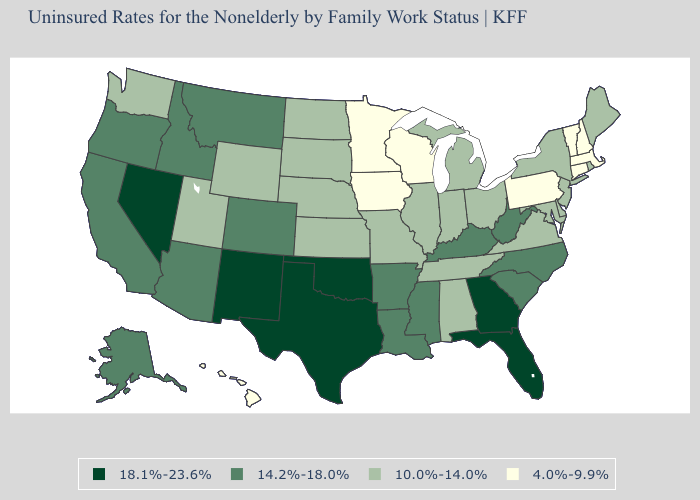What is the value of Kansas?
Answer briefly. 10.0%-14.0%. What is the highest value in the USA?
Write a very short answer. 18.1%-23.6%. What is the highest value in states that border Vermont?
Concise answer only. 10.0%-14.0%. What is the value of Arkansas?
Quick response, please. 14.2%-18.0%. Does Iowa have a lower value than Oklahoma?
Concise answer only. Yes. Name the states that have a value in the range 10.0%-14.0%?
Be succinct. Alabama, Delaware, Illinois, Indiana, Kansas, Maine, Maryland, Michigan, Missouri, Nebraska, New Jersey, New York, North Dakota, Ohio, Rhode Island, South Dakota, Tennessee, Utah, Virginia, Washington, Wyoming. Which states have the lowest value in the Northeast?
Keep it brief. Connecticut, Massachusetts, New Hampshire, Pennsylvania, Vermont. What is the lowest value in the MidWest?
Quick response, please. 4.0%-9.9%. Name the states that have a value in the range 4.0%-9.9%?
Give a very brief answer. Connecticut, Hawaii, Iowa, Massachusetts, Minnesota, New Hampshire, Pennsylvania, Vermont, Wisconsin. Name the states that have a value in the range 18.1%-23.6%?
Answer briefly. Florida, Georgia, Nevada, New Mexico, Oklahoma, Texas. What is the value of Massachusetts?
Answer briefly. 4.0%-9.9%. Which states have the lowest value in the South?
Answer briefly. Alabama, Delaware, Maryland, Tennessee, Virginia. What is the value of Maine?
Answer briefly. 10.0%-14.0%. Which states have the lowest value in the West?
Answer briefly. Hawaii. 